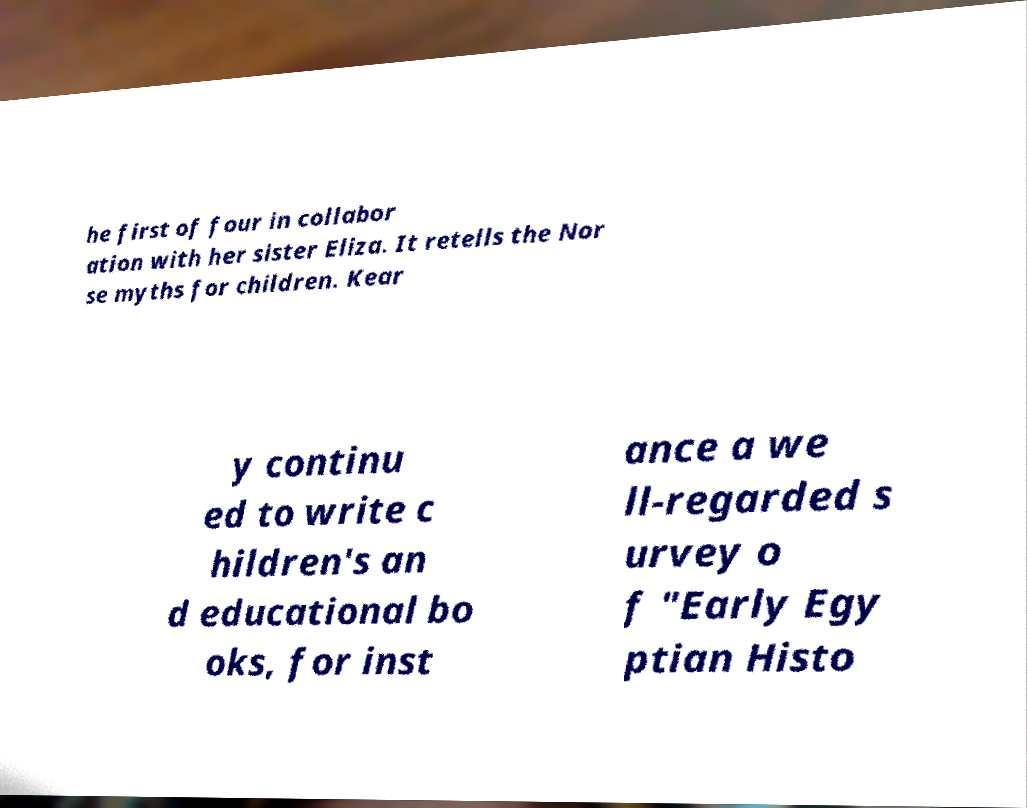Please read and relay the text visible in this image. What does it say? he first of four in collabor ation with her sister Eliza. It retells the Nor se myths for children. Kear y continu ed to write c hildren's an d educational bo oks, for inst ance a we ll-regarded s urvey o f "Early Egy ptian Histo 